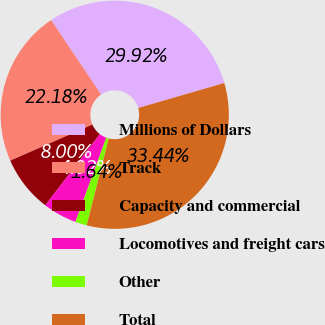Convert chart. <chart><loc_0><loc_0><loc_500><loc_500><pie_chart><fcel>Millions of Dollars<fcel>Track<fcel>Capacity and commercial<fcel>Locomotives and freight cars<fcel>Other<fcel>Total<nl><fcel>29.92%<fcel>22.18%<fcel>8.0%<fcel>4.82%<fcel>1.64%<fcel>33.44%<nl></chart> 